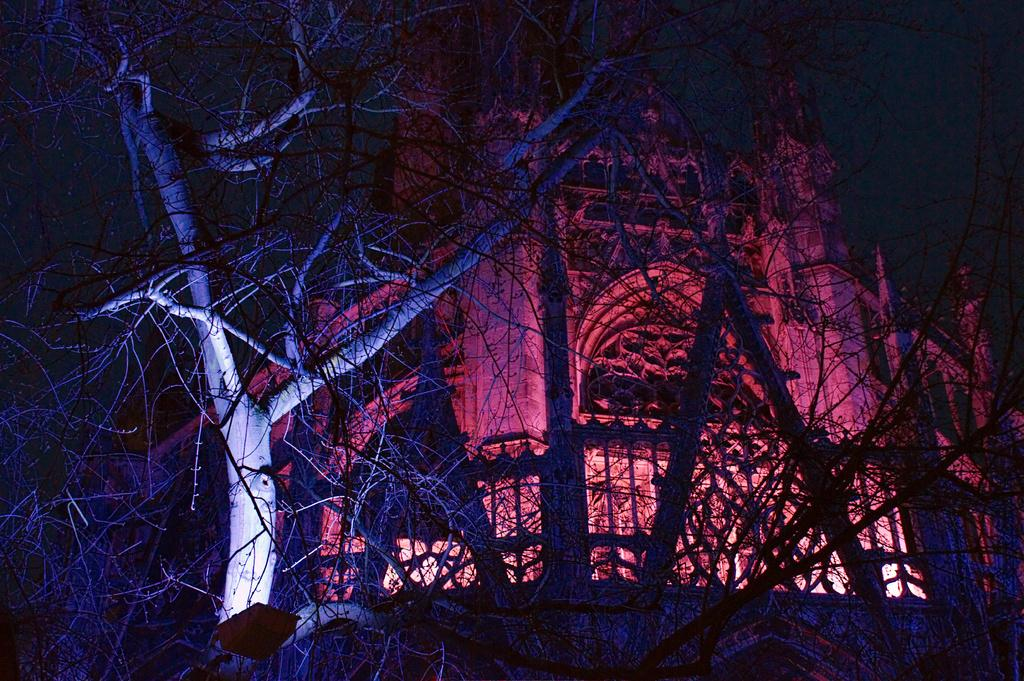What type of vegetation is at the bottom of the image? There are trees at the bottom of the image. What type of structure can be seen in the background of the image? There is a building in the background of the image. What type of crime is being committed in the image? There is no indication of any crime being committed in the image. Is there a jail visible in the image? There is no jail present in the image. 